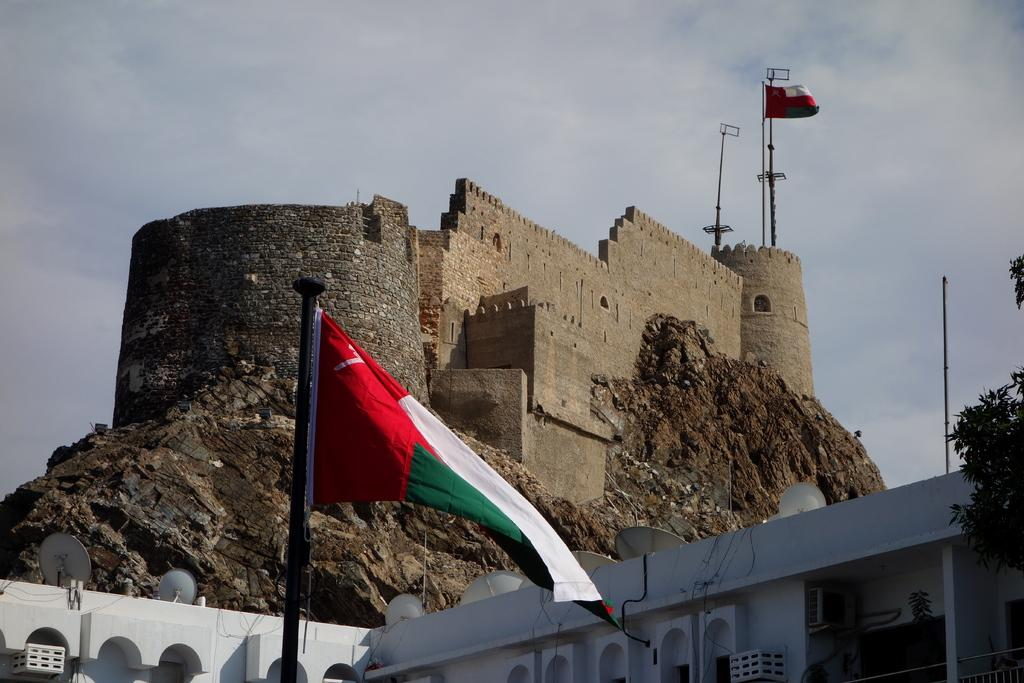What colors are present on the flag in the image? The flag in the image has red, green, and white colors. What type of structure can be seen in the image? There is a fort visible in the image. What is the color of the building in the image? The building in the image is white-colored. What type of vegetation is present in the image? Trees are present in the image. What colors can be seen in the sky in the image? The sky in the image is a combination of white and blue colors. How many fish are swimming in the water near the fort in the image? There are no fish or water present in the image; it features a flag, a fort, a white-colored building, trees, and a sky with white and blue colors. What type of uniform is the fireman wearing in the image? There is no fireman present in the image. 